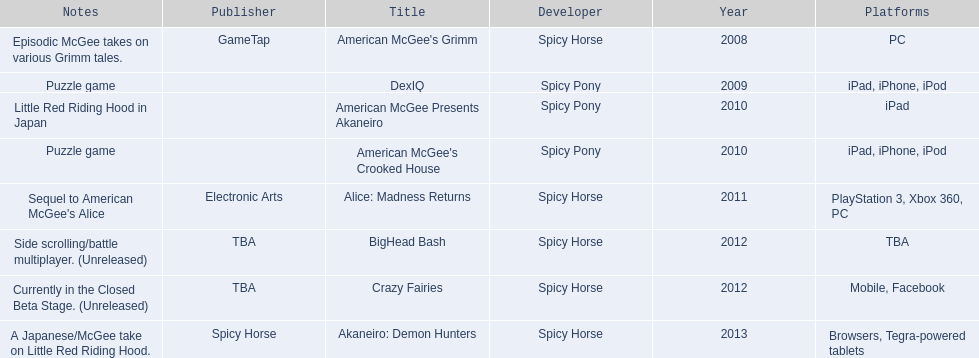What are all the titles of games published? American McGee's Grimm, DexIQ, American McGee Presents Akaneiro, American McGee's Crooked House, Alice: Madness Returns, BigHead Bash, Crazy Fairies, Akaneiro: Demon Hunters. What are all the names of the publishers? GameTap, , , , Electronic Arts, TBA, TBA, Spicy Horse. What is the published game title that corresponds to electronic arts? Alice: Madness Returns. 